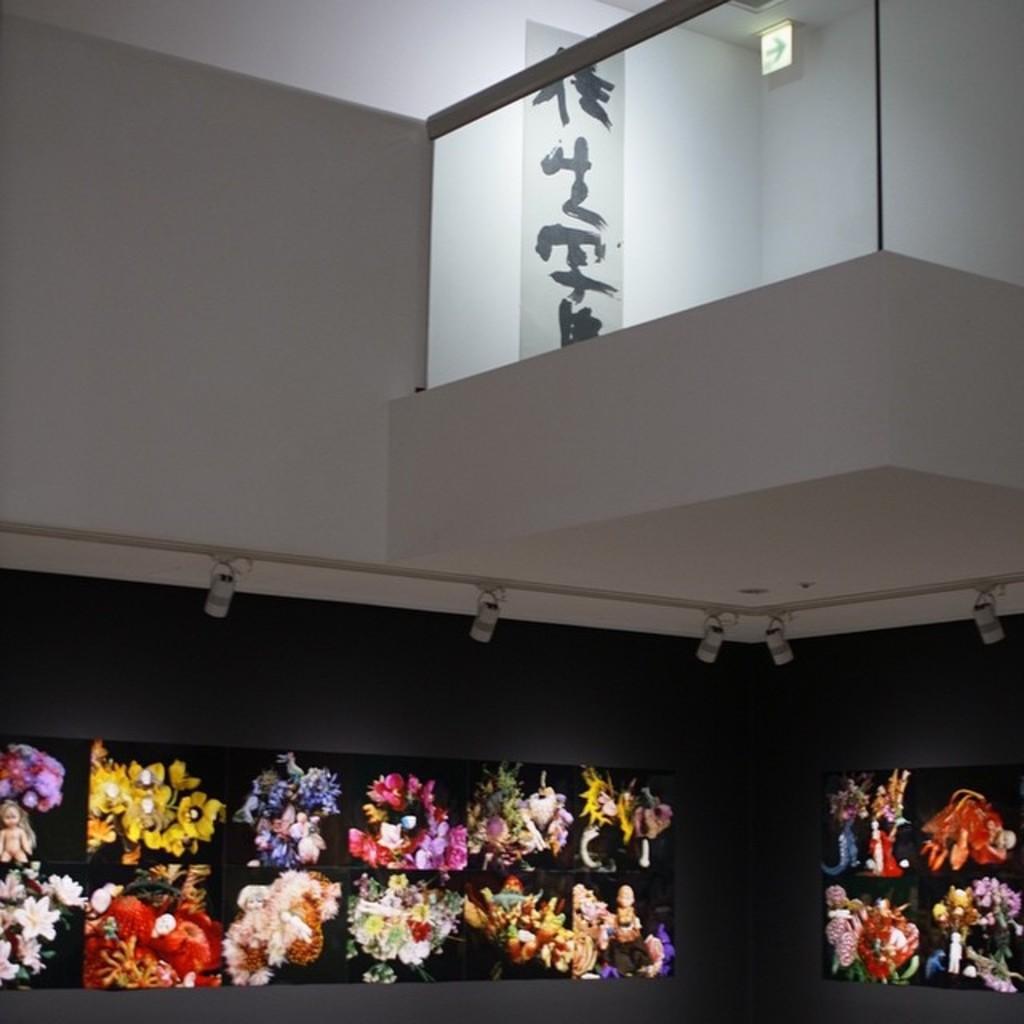How would you summarize this image in a sentence or two? In this image there are flowers and dolls on the cupboards. Above the cupboards there are lamps. Above the lambs there is a wall. Beside the wall there is a glass fence. In the background of the image there is a poster attached to the wall. 